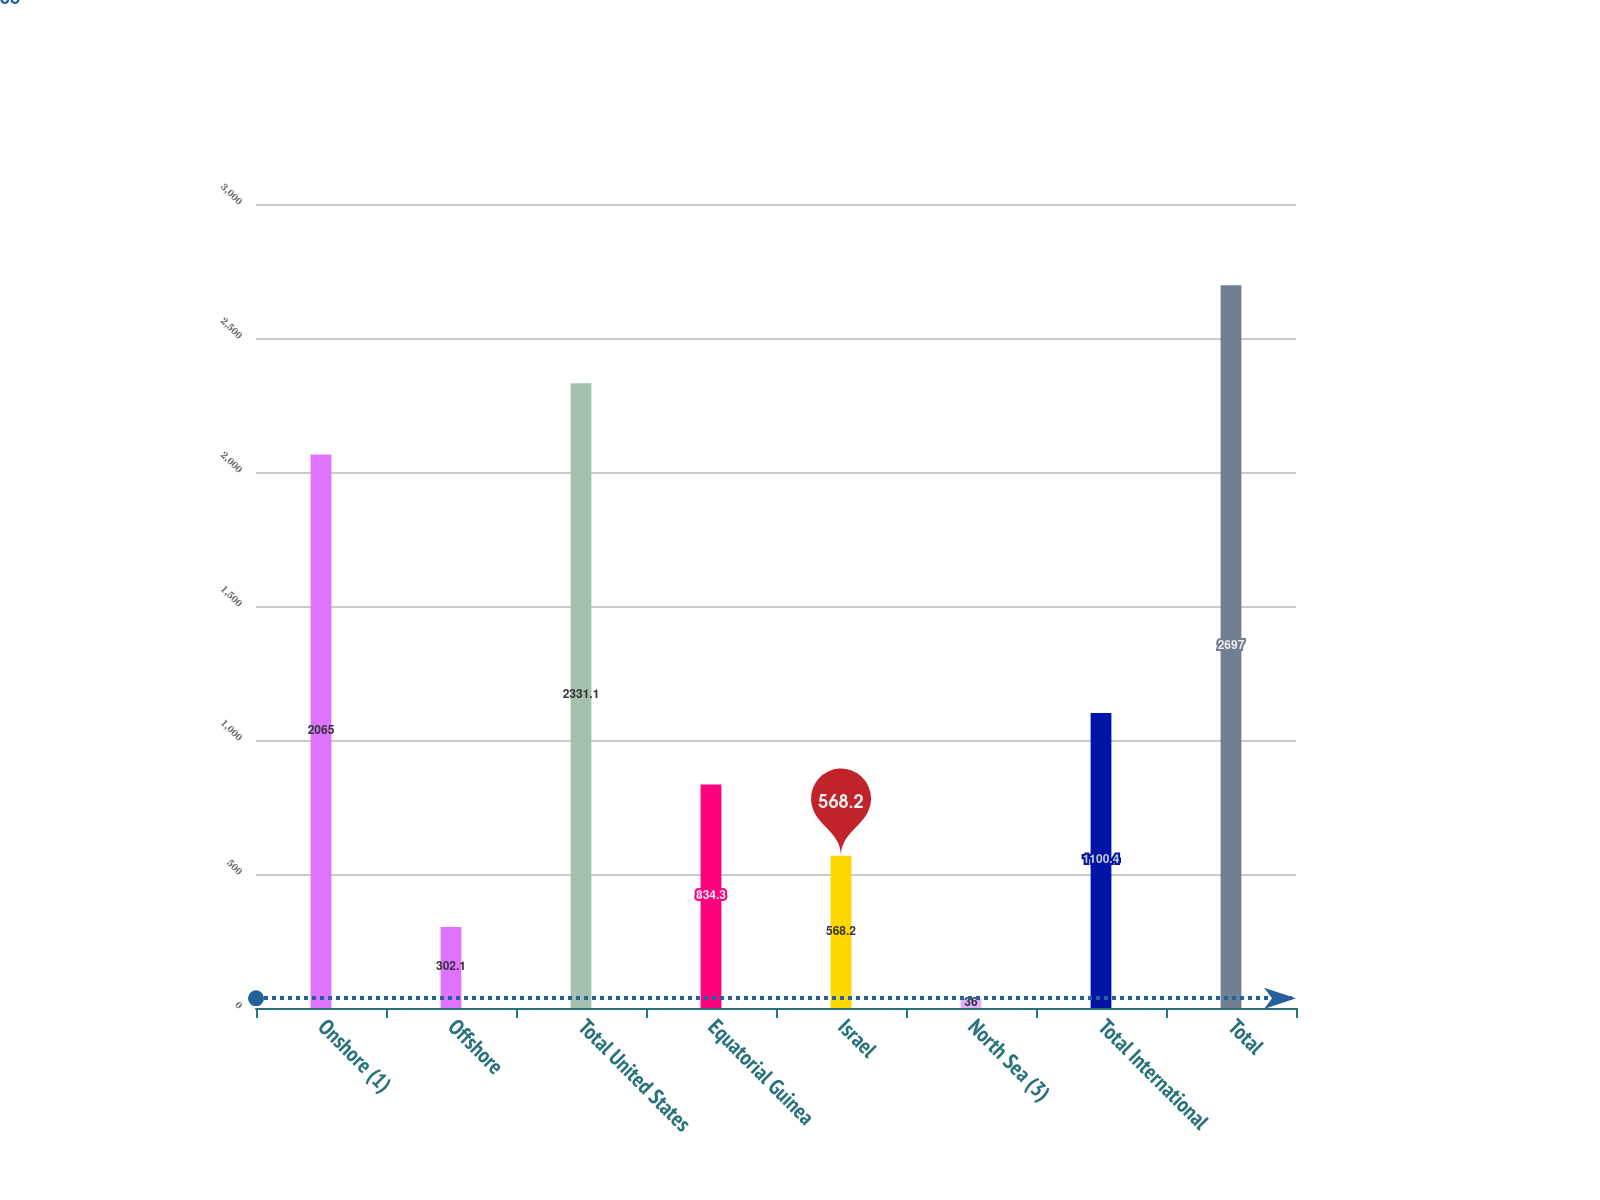<chart> <loc_0><loc_0><loc_500><loc_500><bar_chart><fcel>Onshore (1)<fcel>Offshore<fcel>Total United States<fcel>Equatorial Guinea<fcel>Israel<fcel>North Sea (3)<fcel>Total International<fcel>Total<nl><fcel>2065<fcel>302.1<fcel>2331.1<fcel>834.3<fcel>568.2<fcel>36<fcel>1100.4<fcel>2697<nl></chart> 